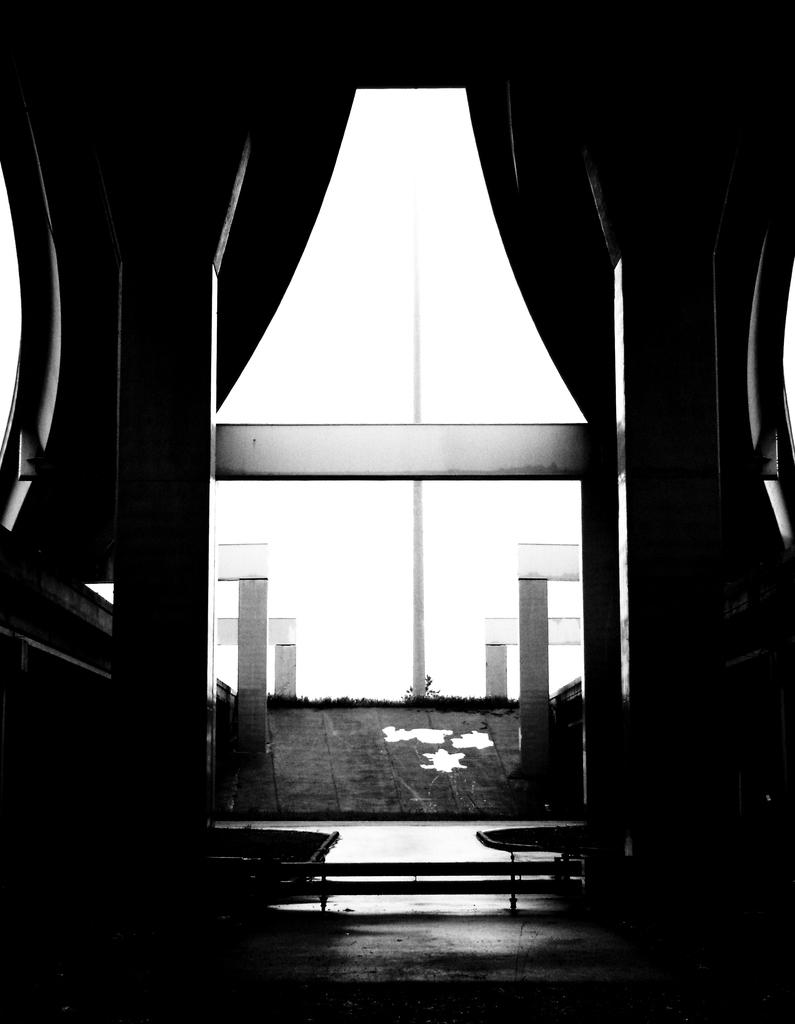What is the color scheme of the image? The image is black and white. What type of structure can be seen in the image? There is a building in the image. What is located at the top of the image? There is a curtain at the top of the image. What is in the middle of the image? There is a pole in the middle of the image. How does the comb help in the development of the building in the image? There is no comb present in the image, and therefore it cannot contribute to the development of the building. 